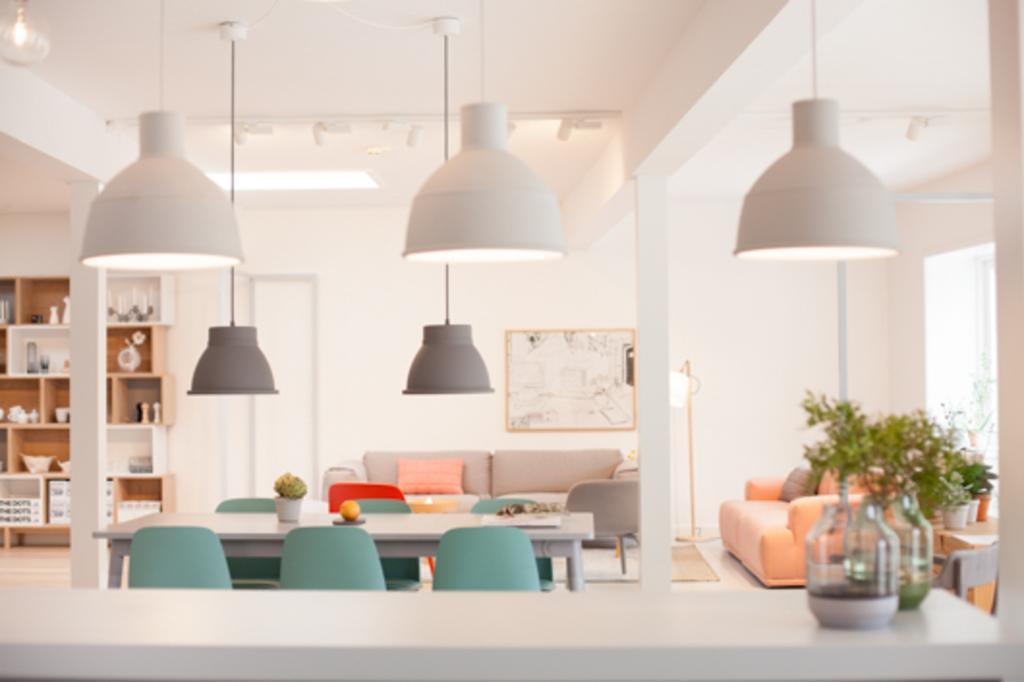Describe this image in one or two sentences. In this image we can see a sofa and pillows on it, in front here is the table, and flower pot on it, there are chairs on the floor, at back there are some objects in the rack, at above there are lights, there is a wall and a photo frame on it. 